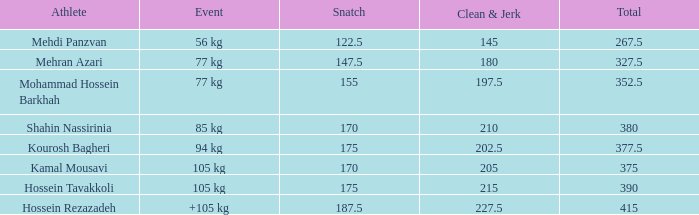How many snatches amounted to a total of 26 0.0. 